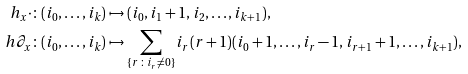Convert formula to latex. <formula><loc_0><loc_0><loc_500><loc_500>h _ { x } \cdot \colon ( i _ { 0 } , \dots , i _ { k } ) & \mapsto ( i _ { 0 } , i _ { 1 } + 1 , i _ { 2 } , \dots , i _ { k + 1 } ) , \\ h \partial _ { x } \colon ( i _ { 0 } , \dots , i _ { k } ) & \mapsto \sum _ { \{ r \, \colon \, i _ { r } \ne 0 \} } i _ { r } ( r + 1 ) ( i _ { 0 } + 1 , \dots , i _ { r } - 1 , i _ { r + 1 } + 1 , \dots , i _ { k + 1 } ) ,</formula> 